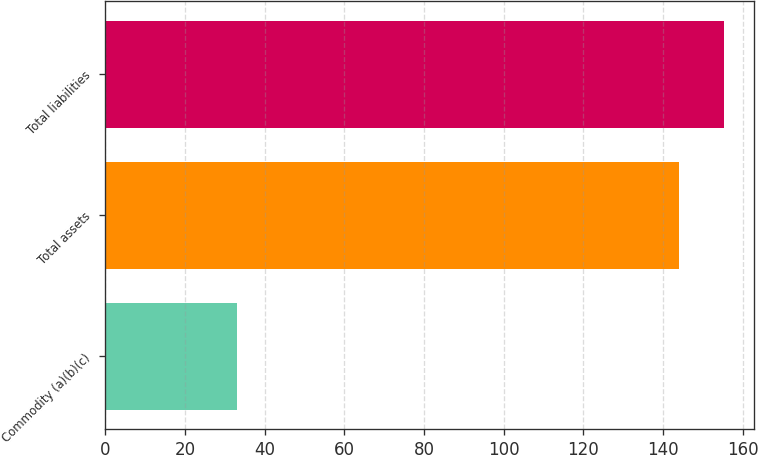Convert chart to OTSL. <chart><loc_0><loc_0><loc_500><loc_500><bar_chart><fcel>Commodity (a)(b)(c)<fcel>Total assets<fcel>Total liabilities<nl><fcel>33<fcel>144<fcel>155.2<nl></chart> 